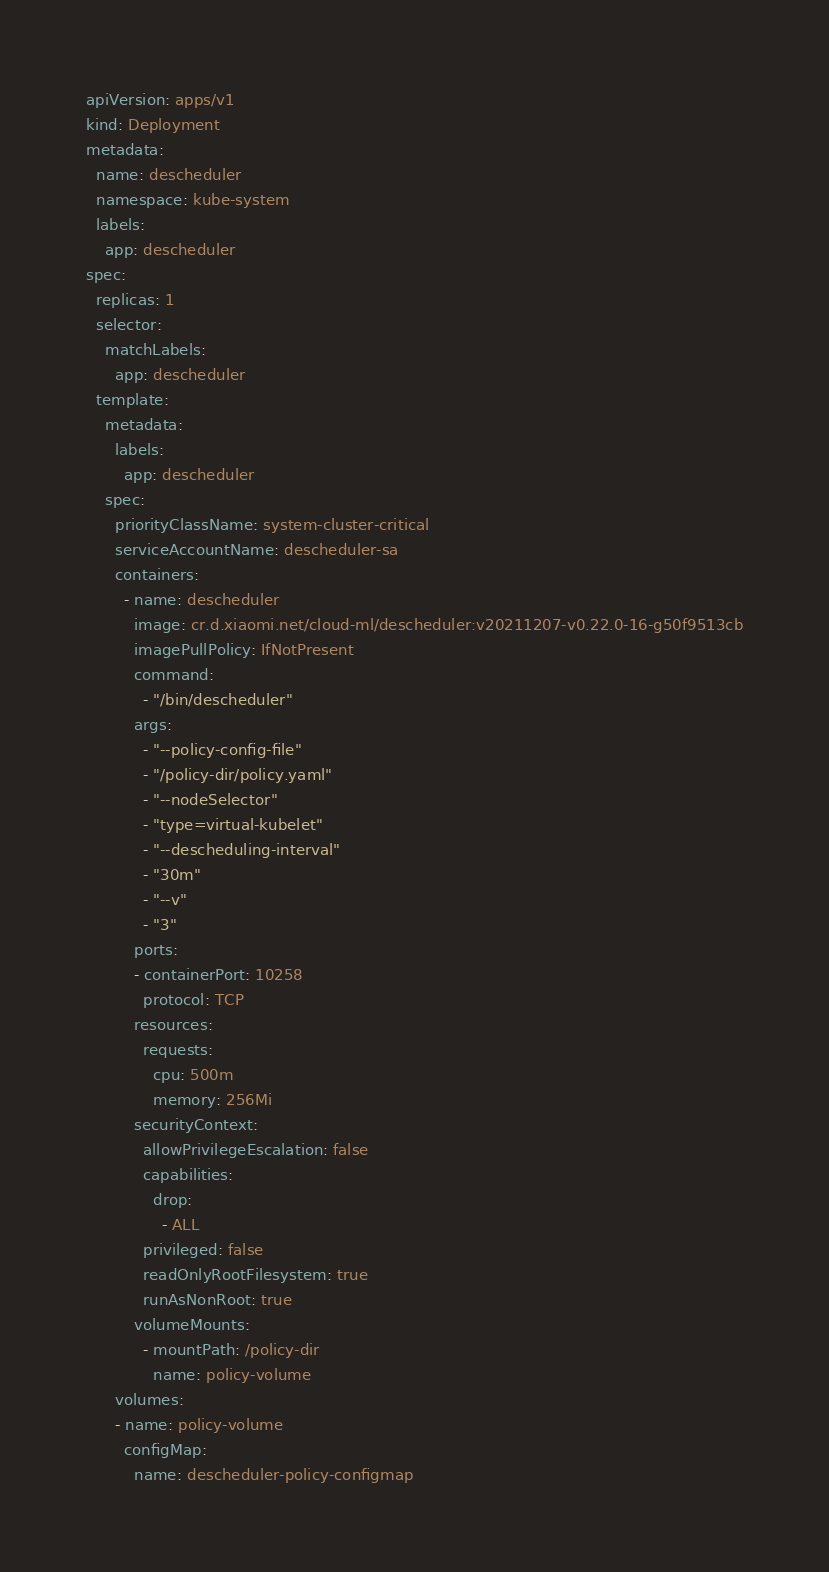Convert code to text. <code><loc_0><loc_0><loc_500><loc_500><_YAML_>apiVersion: apps/v1
kind: Deployment
metadata:
  name: descheduler
  namespace: kube-system
  labels:
    app: descheduler
spec:
  replicas: 1
  selector:
    matchLabels:
      app: descheduler
  template:
    metadata:
      labels:
        app: descheduler
    spec:
      priorityClassName: system-cluster-critical
      serviceAccountName: descheduler-sa
      containers:
        - name: descheduler
          image: cr.d.xiaomi.net/cloud-ml/descheduler:v20211207-v0.22.0-16-g50f9513cb
          imagePullPolicy: IfNotPresent
          command:
            - "/bin/descheduler"
          args:
            - "--policy-config-file"
            - "/policy-dir/policy.yaml"
            - "--nodeSelector"
            - "type=virtual-kubelet"
            - "--descheduling-interval"
            - "30m"
            - "--v"
            - "3"
          ports:
          - containerPort: 10258
            protocol: TCP
          resources:
            requests:
              cpu: 500m
              memory: 256Mi
          securityContext:
            allowPrivilegeEscalation: false
            capabilities:
              drop:
                - ALL
            privileged: false
            readOnlyRootFilesystem: true
            runAsNonRoot: true
          volumeMounts:
            - mountPath: /policy-dir
              name: policy-volume
      volumes:
      - name: policy-volume
        configMap:
          name: descheduler-policy-configmap
</code> 